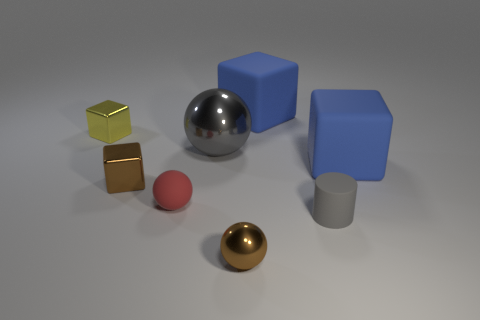Add 2 large blocks. How many objects exist? 10 Subtract all cylinders. How many objects are left? 7 Subtract all purple rubber things. Subtract all metallic cubes. How many objects are left? 6 Add 5 gray cylinders. How many gray cylinders are left? 6 Add 3 brown metal things. How many brown metal things exist? 5 Subtract 0 green spheres. How many objects are left? 8 